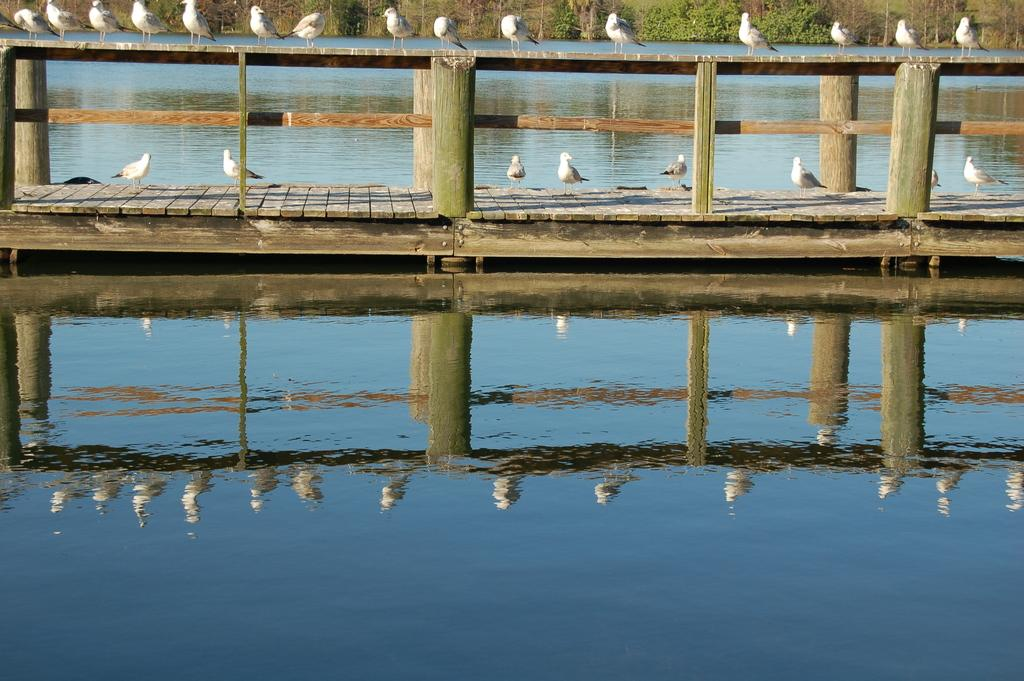What is the main subject of the image? The main subject of the image is many birds. Where are the birds located in the image? The birds are standing on a bridge. What is the bridge positioned over in the image? The bridge is over a lake. What can be seen in the background of the image? There are trees in the background of the image. How many loaves of bread are being held by the person in the image? There is no person present in the image, and therefore no loaves of bread can be observed. 